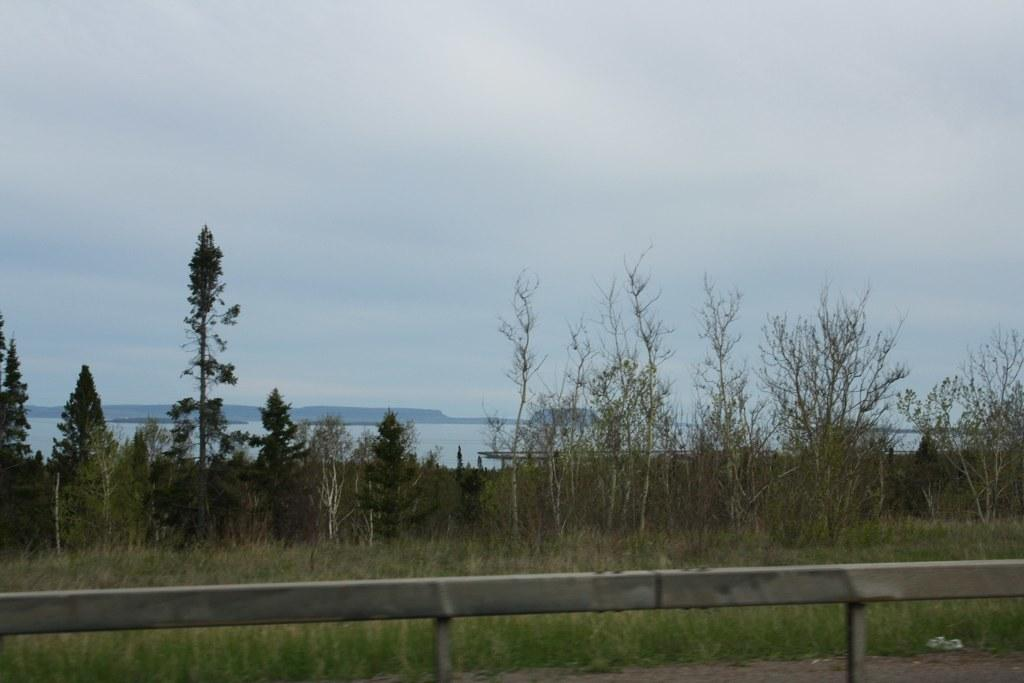What type of structure can be seen in the image? There is a fence in the image. What type of vegetation is present in the image? There is grass in the image. What other natural elements can be seen in the image? There are trees and water visible in the image. What type of landscape feature is present in the image? There are hills in the image. What is the condition of the sky in the background of the image? The sky in the background is cloudy. Where is the brother of the person taking the picture in the image? There is no person taking the picture mentioned in the facts, nor is there any reference to a brother. What type of geological formation is present in the image? There is no mention of a volcano or any other geological formation in the image. 